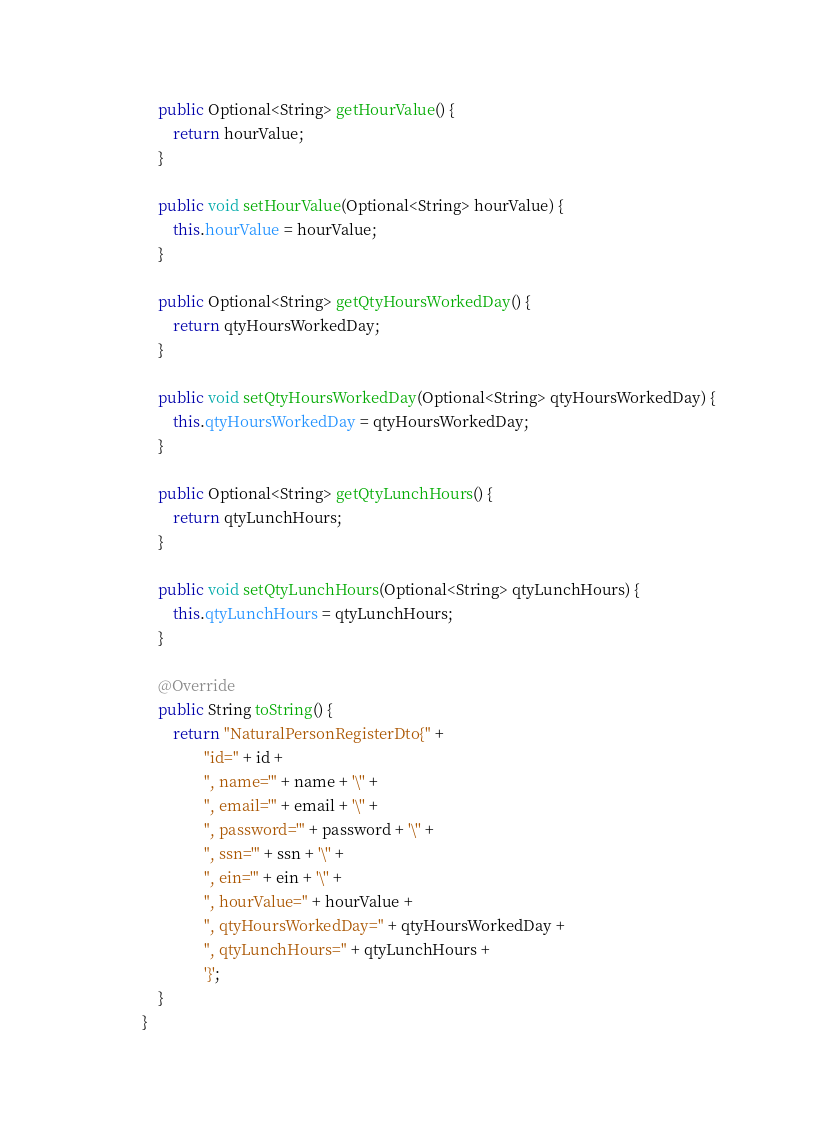<code> <loc_0><loc_0><loc_500><loc_500><_Java_>
    public Optional<String> getHourValue() {
        return hourValue;
    }

    public void setHourValue(Optional<String> hourValue) {
        this.hourValue = hourValue;
    }

    public Optional<String> getQtyHoursWorkedDay() {
        return qtyHoursWorkedDay;
    }

    public void setQtyHoursWorkedDay(Optional<String> qtyHoursWorkedDay) {
        this.qtyHoursWorkedDay = qtyHoursWorkedDay;
    }

    public Optional<String> getQtyLunchHours() {
        return qtyLunchHours;
    }

    public void setQtyLunchHours(Optional<String> qtyLunchHours) {
        this.qtyLunchHours = qtyLunchHours;
    }

    @Override
    public String toString() {
        return "NaturalPersonRegisterDto{" +
                "id=" + id +
                ", name='" + name + '\'' +
                ", email='" + email + '\'' +
                ", password='" + password + '\'' +
                ", ssn='" + ssn + '\'' +
                ", ein='" + ein + '\'' +
                ", hourValue=" + hourValue +
                ", qtyHoursWorkedDay=" + qtyHoursWorkedDay +
                ", qtyLunchHours=" + qtyLunchHours +
                '}';
    }
}
</code> 